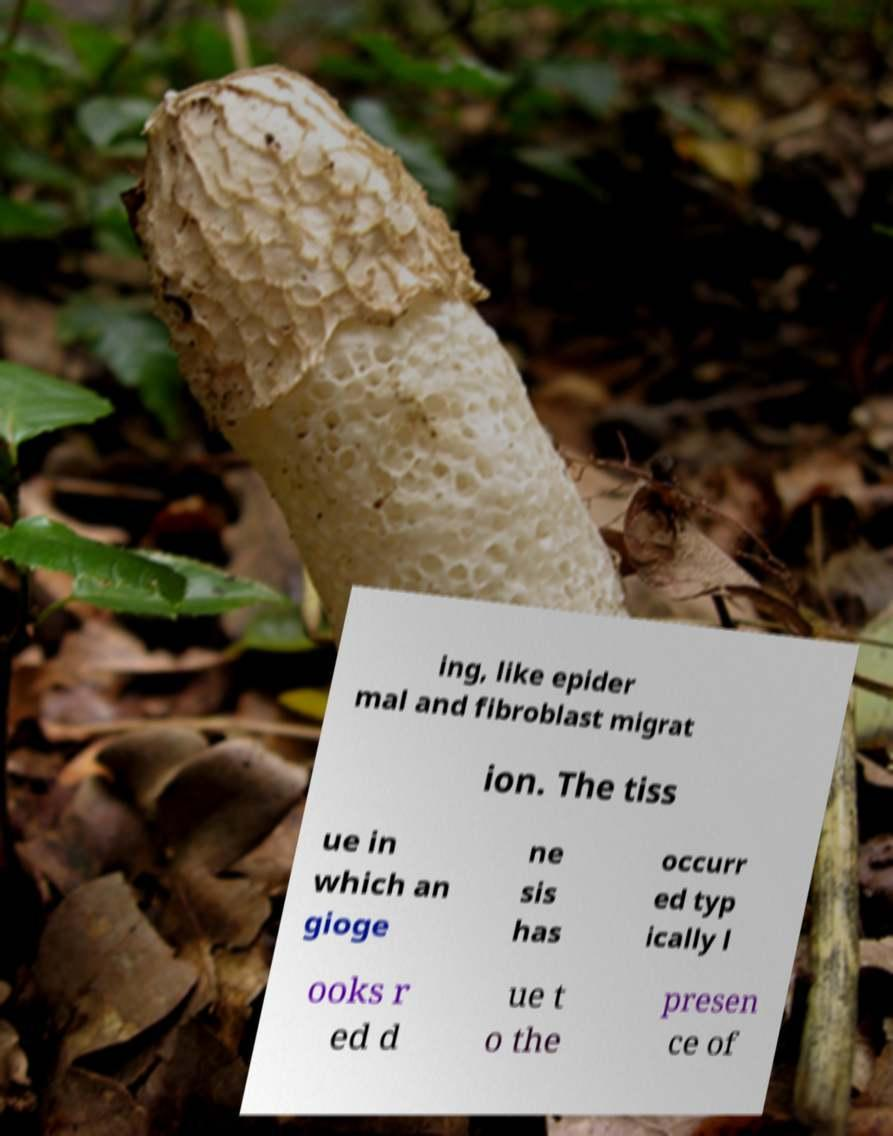What messages or text are displayed in this image? I need them in a readable, typed format. ing, like epider mal and fibroblast migrat ion. The tiss ue in which an gioge ne sis has occurr ed typ ically l ooks r ed d ue t o the presen ce of 